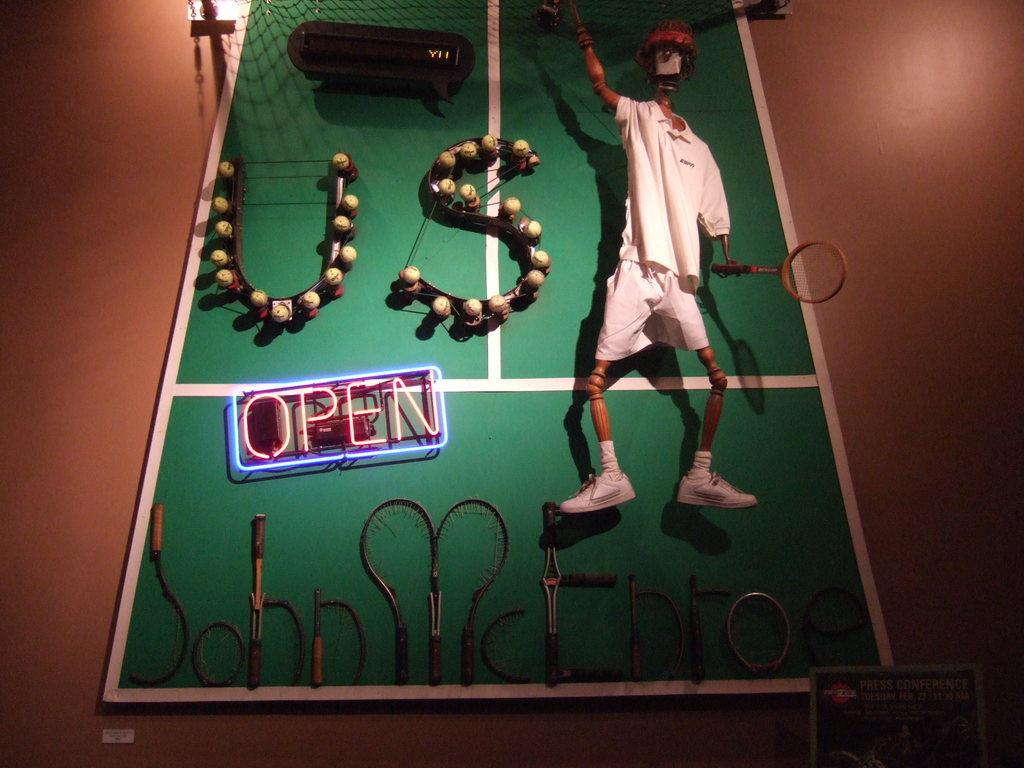What type of sports facility is visible in the image? There is a tennis court in the image. What is the player holding in the image? The player is holding a tennis racket. What event is the tennis court associated with? The text "US OPEN" is written on the tennis court, indicating it is related to the US Open tennis tournament. Where is the additional text located in the image? The text is written below the "US OPEN" text, bending the tennis rackets, and it is on a wall. Are there any birds flying over the tennis court in the image? There is no mention of birds in the image, so we cannot determine if any are present. 